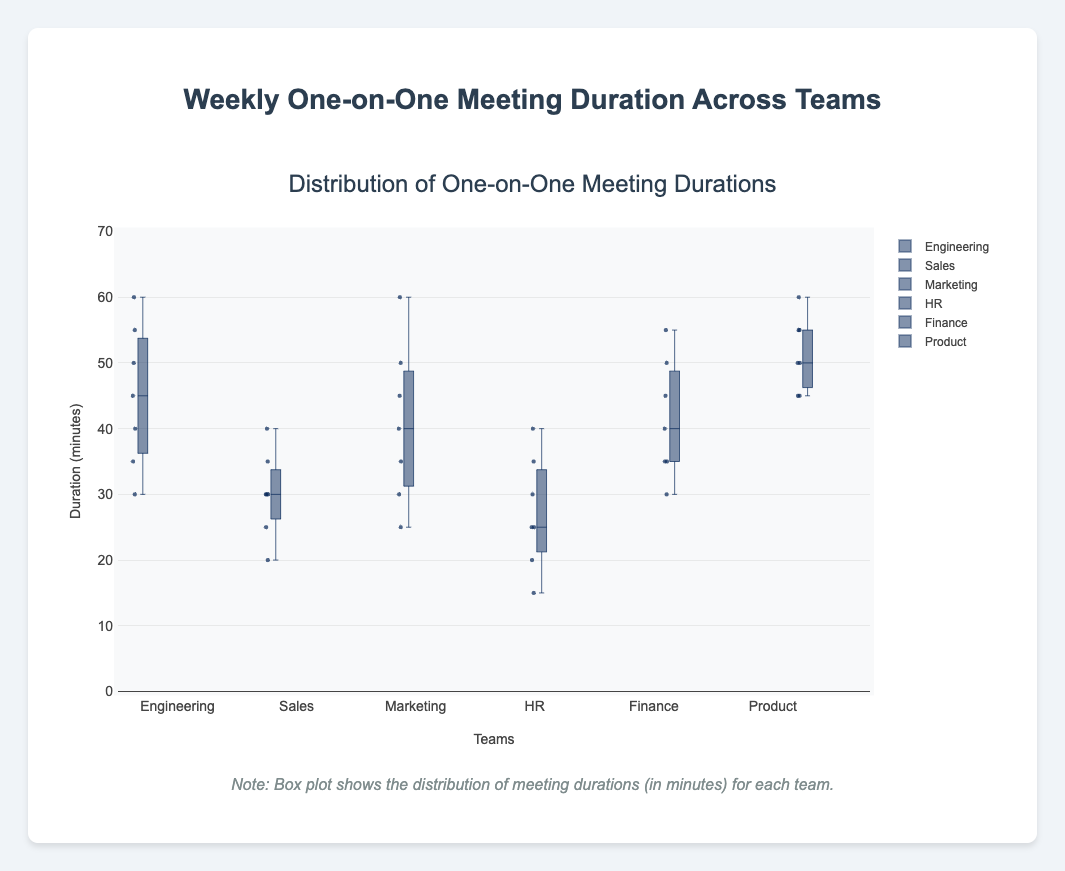What is the title of the plot? The title of the plot is usually located at the top center of the figure. In this case, it is "Weekly One-on-One Meeting Duration Across Teams".
Answer: Weekly One-on-One Meeting Duration Across Teams What does the y-axis represent? We can see from the y-axis label that it represents "Duration (minutes)".
Answer: Duration (minutes) Which team has the highest median meeting duration? To identify the team with the highest median meeting duration, look for the box plot with the highest line inside the box indicating the median. The Product team has the highest median.
Answer: Product Which team has the lowest meeting duration recorded, and what is it? Look for the minimum value (lower whisker) across all box plots. The HR team has the lowest meeting duration recorded at 15 minutes.
Answer: HR, 15 minutes How many teams have a median meeting duration greater than 40 minutes? Check the line inside each box plot to see which have a median above 40. Engineering, Marketing, and Product teams have medians over 40 minutes.
Answer: 3 teams What is the interquartile range (IQR) for the Finance team? The IQR is the difference between the third quartile (Q3) and the first quartile (Q1). For the Finance team, the first quartile is around 35 minutes and the third quartile is around 50 minutes, so IQR = 50 - 35 = 15.
Answer: 15 minutes Which teams have outliers, and what are the outliers? Outliers are the points plotted separately from the box. Engineering has no outliers. Sales has an outlier at 20 minutes. Marketing has an outlier at 60 minutes. HR has no outliers. Finance has no outliers. Product has no outliers.
Answer: Sales (20 minutes), Marketing (60 minutes) Compare the meeting duration range for Sales and HR teams. Which team has a broader range? The range is calculated by subtracting the minimum value from the maximum value. For Sales, it's 40 - 20 = 20 minutes, and for HR it's 40 - 15 = 25 minutes. HR has a broader range.
Answer: HR What is the duration of the shortest meeting, and which team held it? The shortest meeting duration is the minimum value across all box plots, which is 15 minutes by the HR team.
Answer: 15 minutes, HR Which team’s meetings are most consistent in duration (lowest variation)? Consistency is observed by finding the team with the shortest box length, indicating low IQR. The Sales team's box is narrow, indicating the most consistent meeting duration.
Answer: Sales 